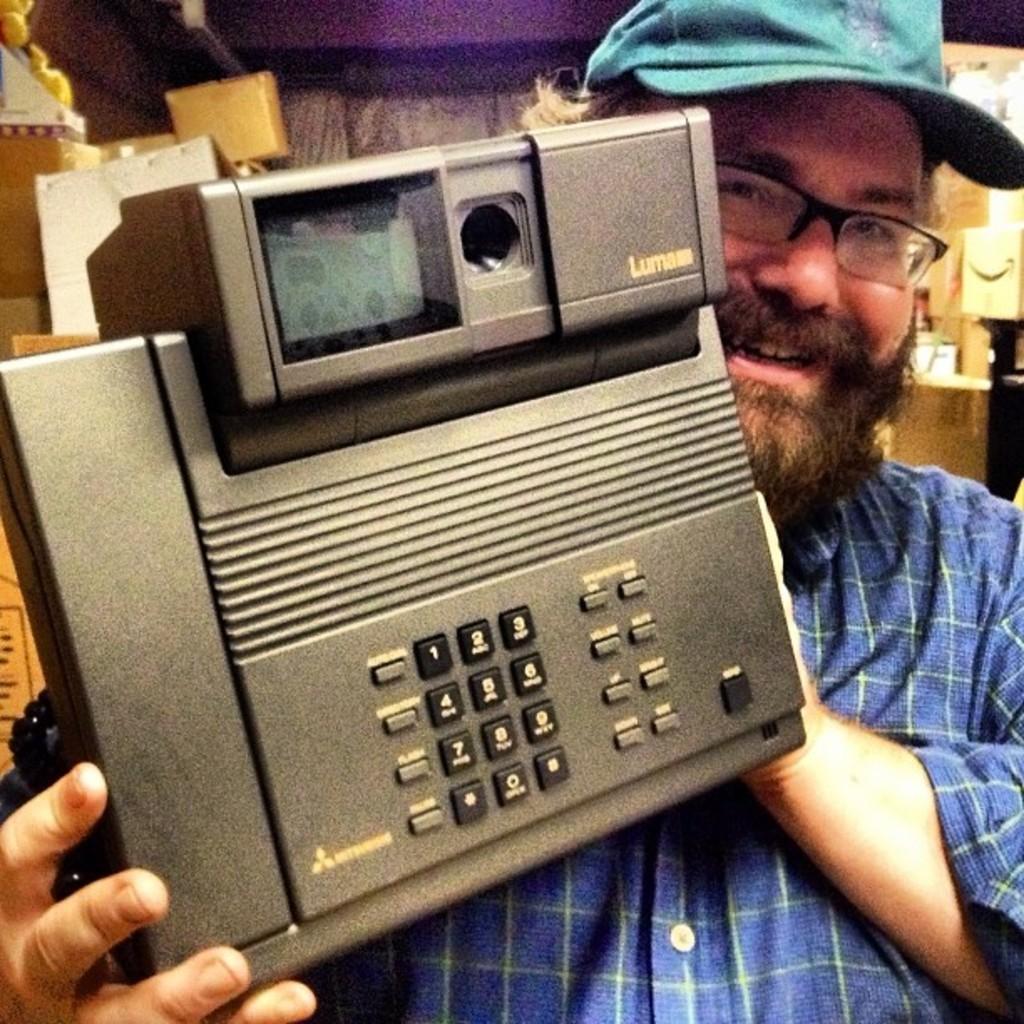Could you give a brief overview of what you see in this image? In this image there is a person standing with a smile on his face and he is holding a telephone in his hand. In the background there are few objects. 